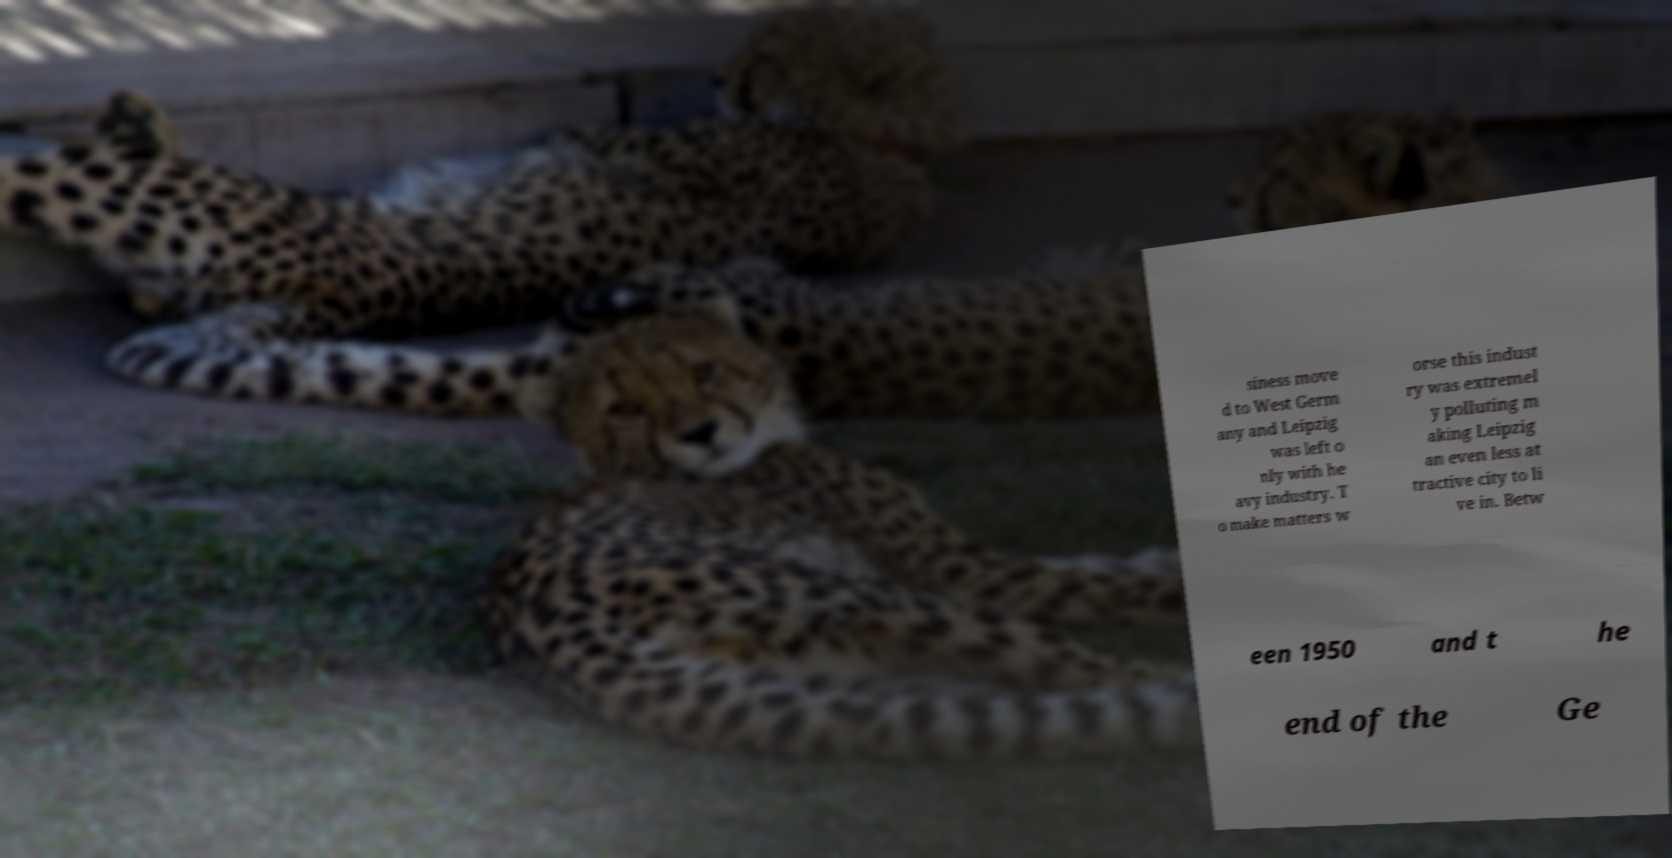Could you extract and type out the text from this image? siness move d to West Germ any and Leipzig was left o nly with he avy industry. T o make matters w orse this indust ry was extremel y polluting m aking Leipzig an even less at tractive city to li ve in. Betw een 1950 and t he end of the Ge 